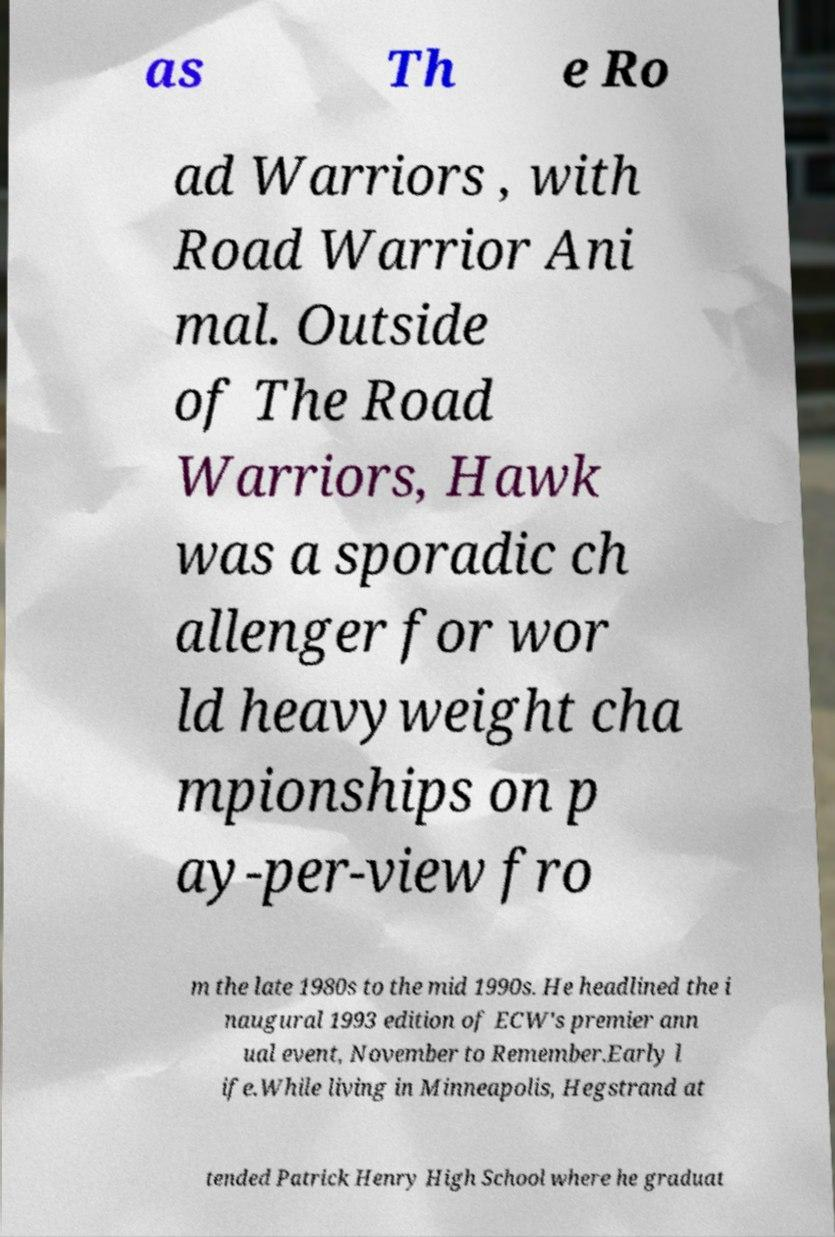Please identify and transcribe the text found in this image. as Th e Ro ad Warriors , with Road Warrior Ani mal. Outside of The Road Warriors, Hawk was a sporadic ch allenger for wor ld heavyweight cha mpionships on p ay-per-view fro m the late 1980s to the mid 1990s. He headlined the i naugural 1993 edition of ECW's premier ann ual event, November to Remember.Early l ife.While living in Minneapolis, Hegstrand at tended Patrick Henry High School where he graduat 